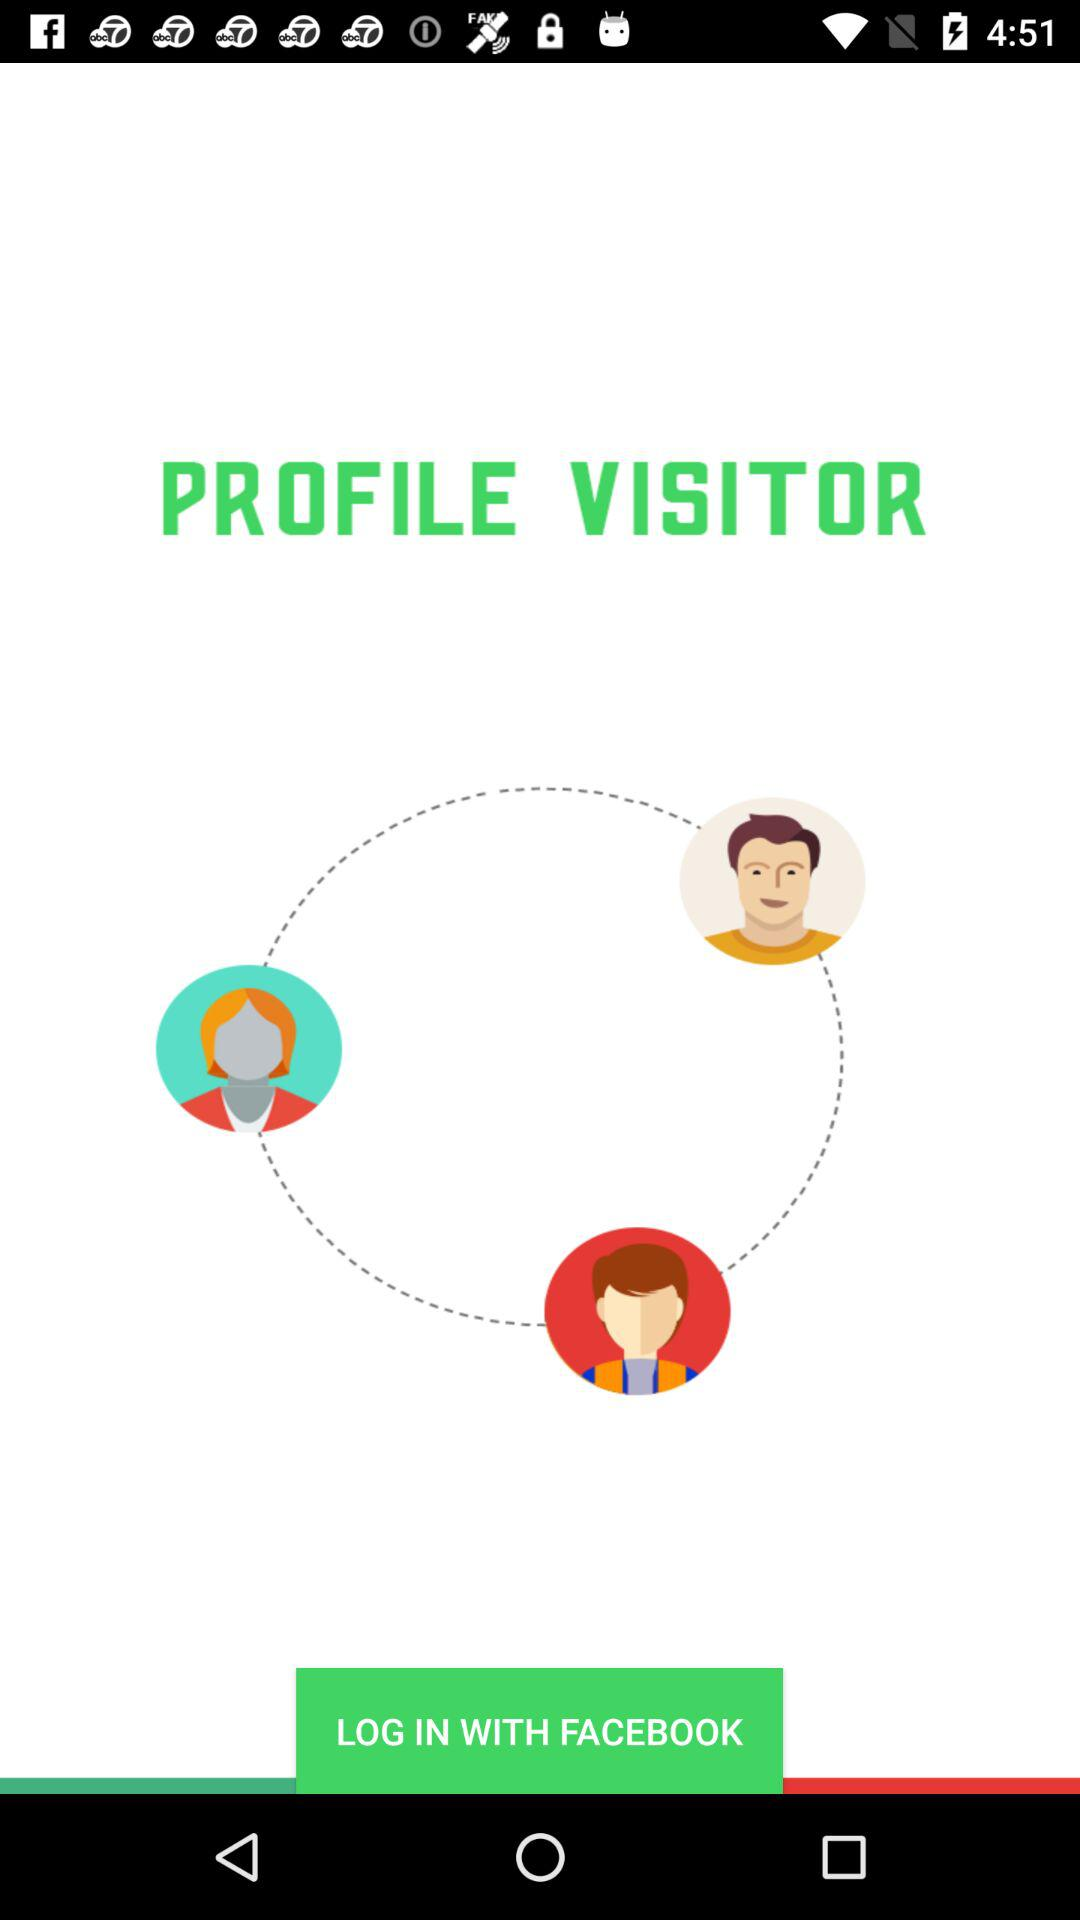Through what application can we log in? You can log in through "FACEBOOK". 